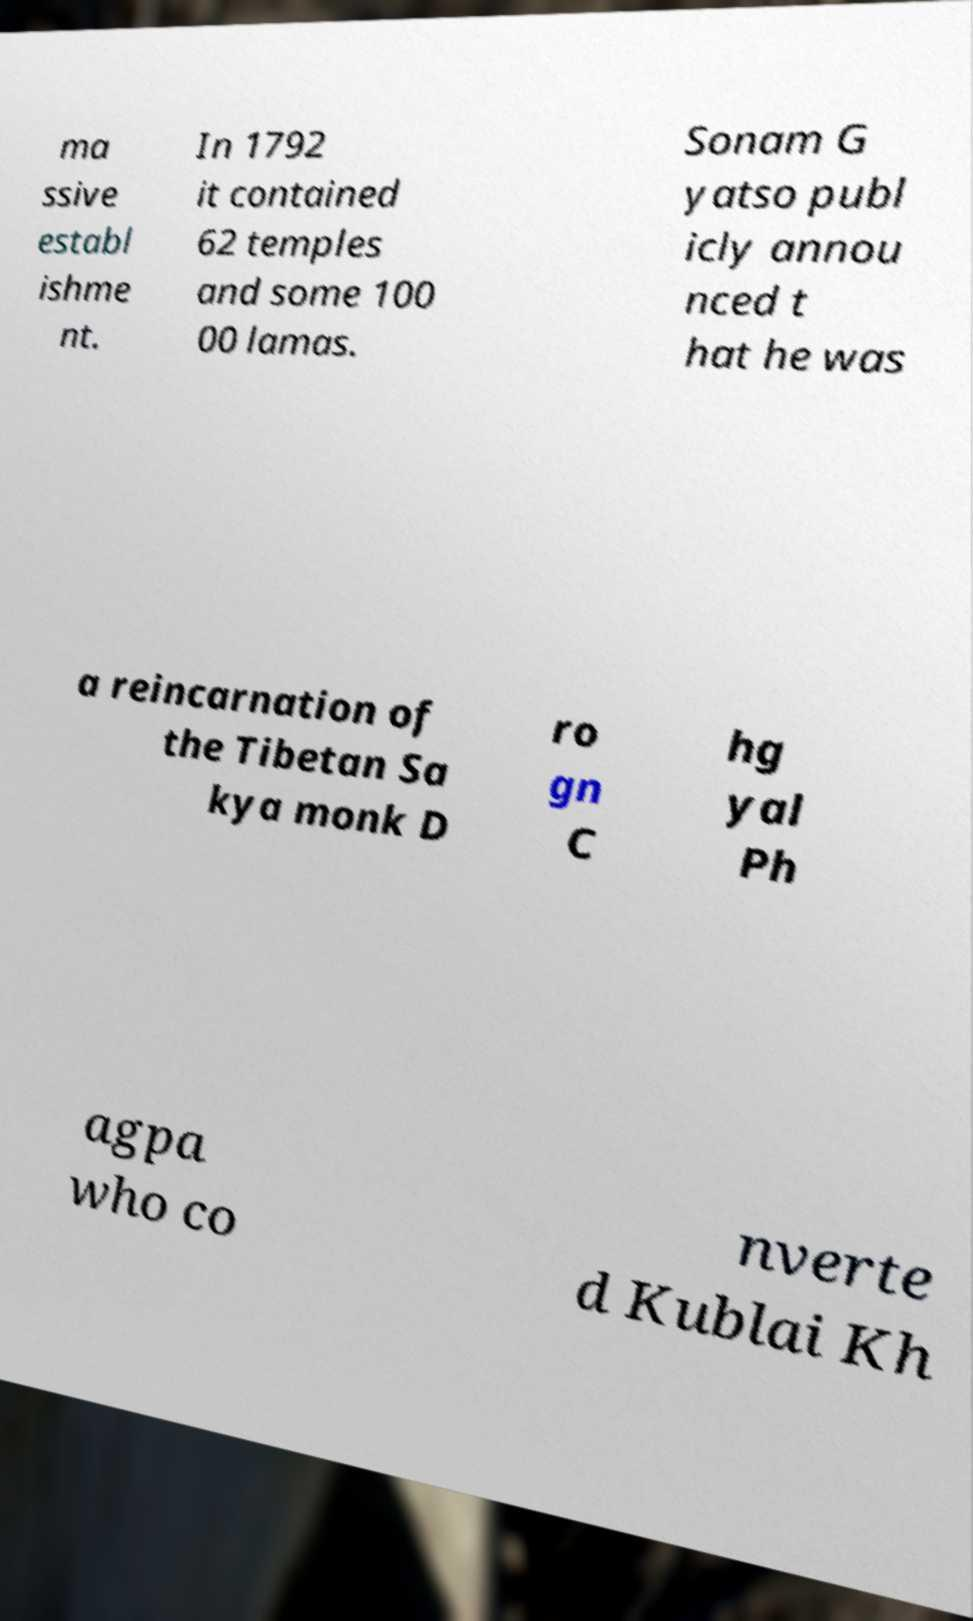For documentation purposes, I need the text within this image transcribed. Could you provide that? ma ssive establ ishme nt. In 1792 it contained 62 temples and some 100 00 lamas. Sonam G yatso publ icly annou nced t hat he was a reincarnation of the Tibetan Sa kya monk D ro gn C hg yal Ph agpa who co nverte d Kublai Kh 